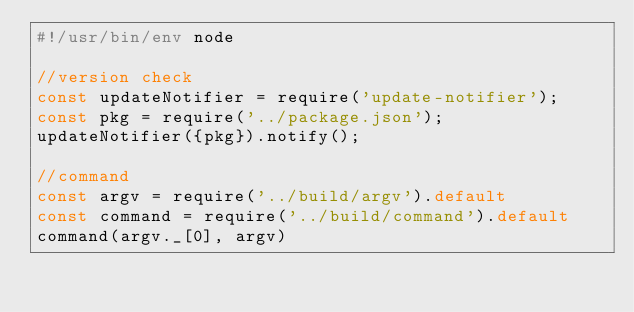<code> <loc_0><loc_0><loc_500><loc_500><_JavaScript_>#!/usr/bin/env node

//version check
const updateNotifier = require('update-notifier');
const pkg = require('../package.json');
updateNotifier({pkg}).notify();

//command
const argv = require('../build/argv').default
const command = require('../build/command').default
command(argv._[0], argv)
</code> 